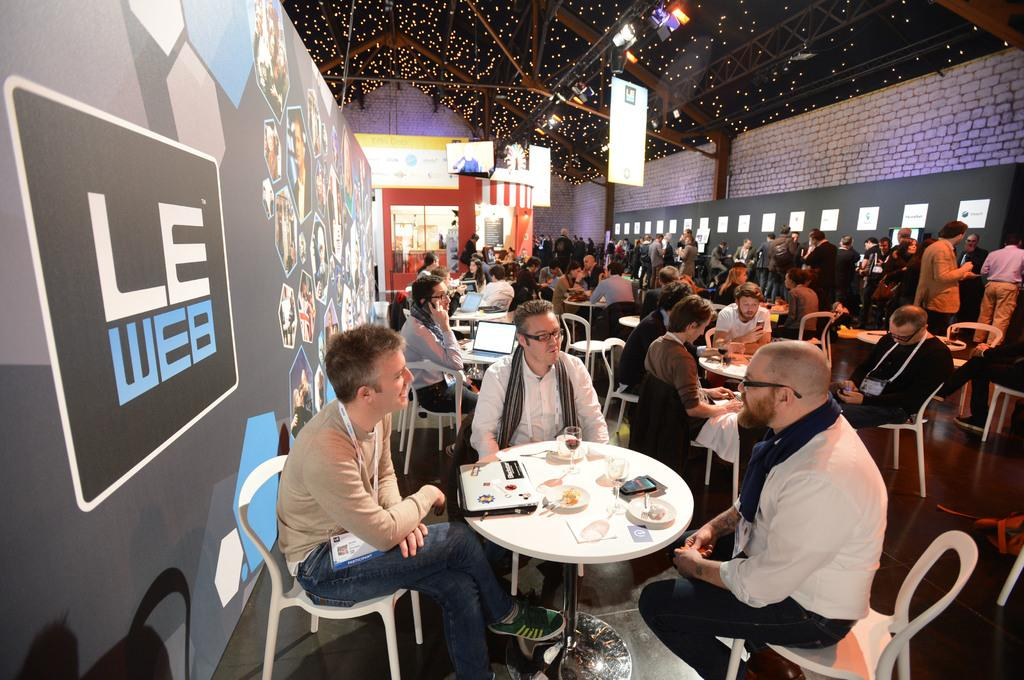What are the people in the image doing? The people in the image are sitting on chairs. How are the chairs arranged in relation to each other? The chairs are arranged around a table. What can be found on the table in the image? There are things on the table. What can be seen in the image that provides illumination? There are lights visible in the image. What type of bird is flying in the image? There is no bird visible in the image. 